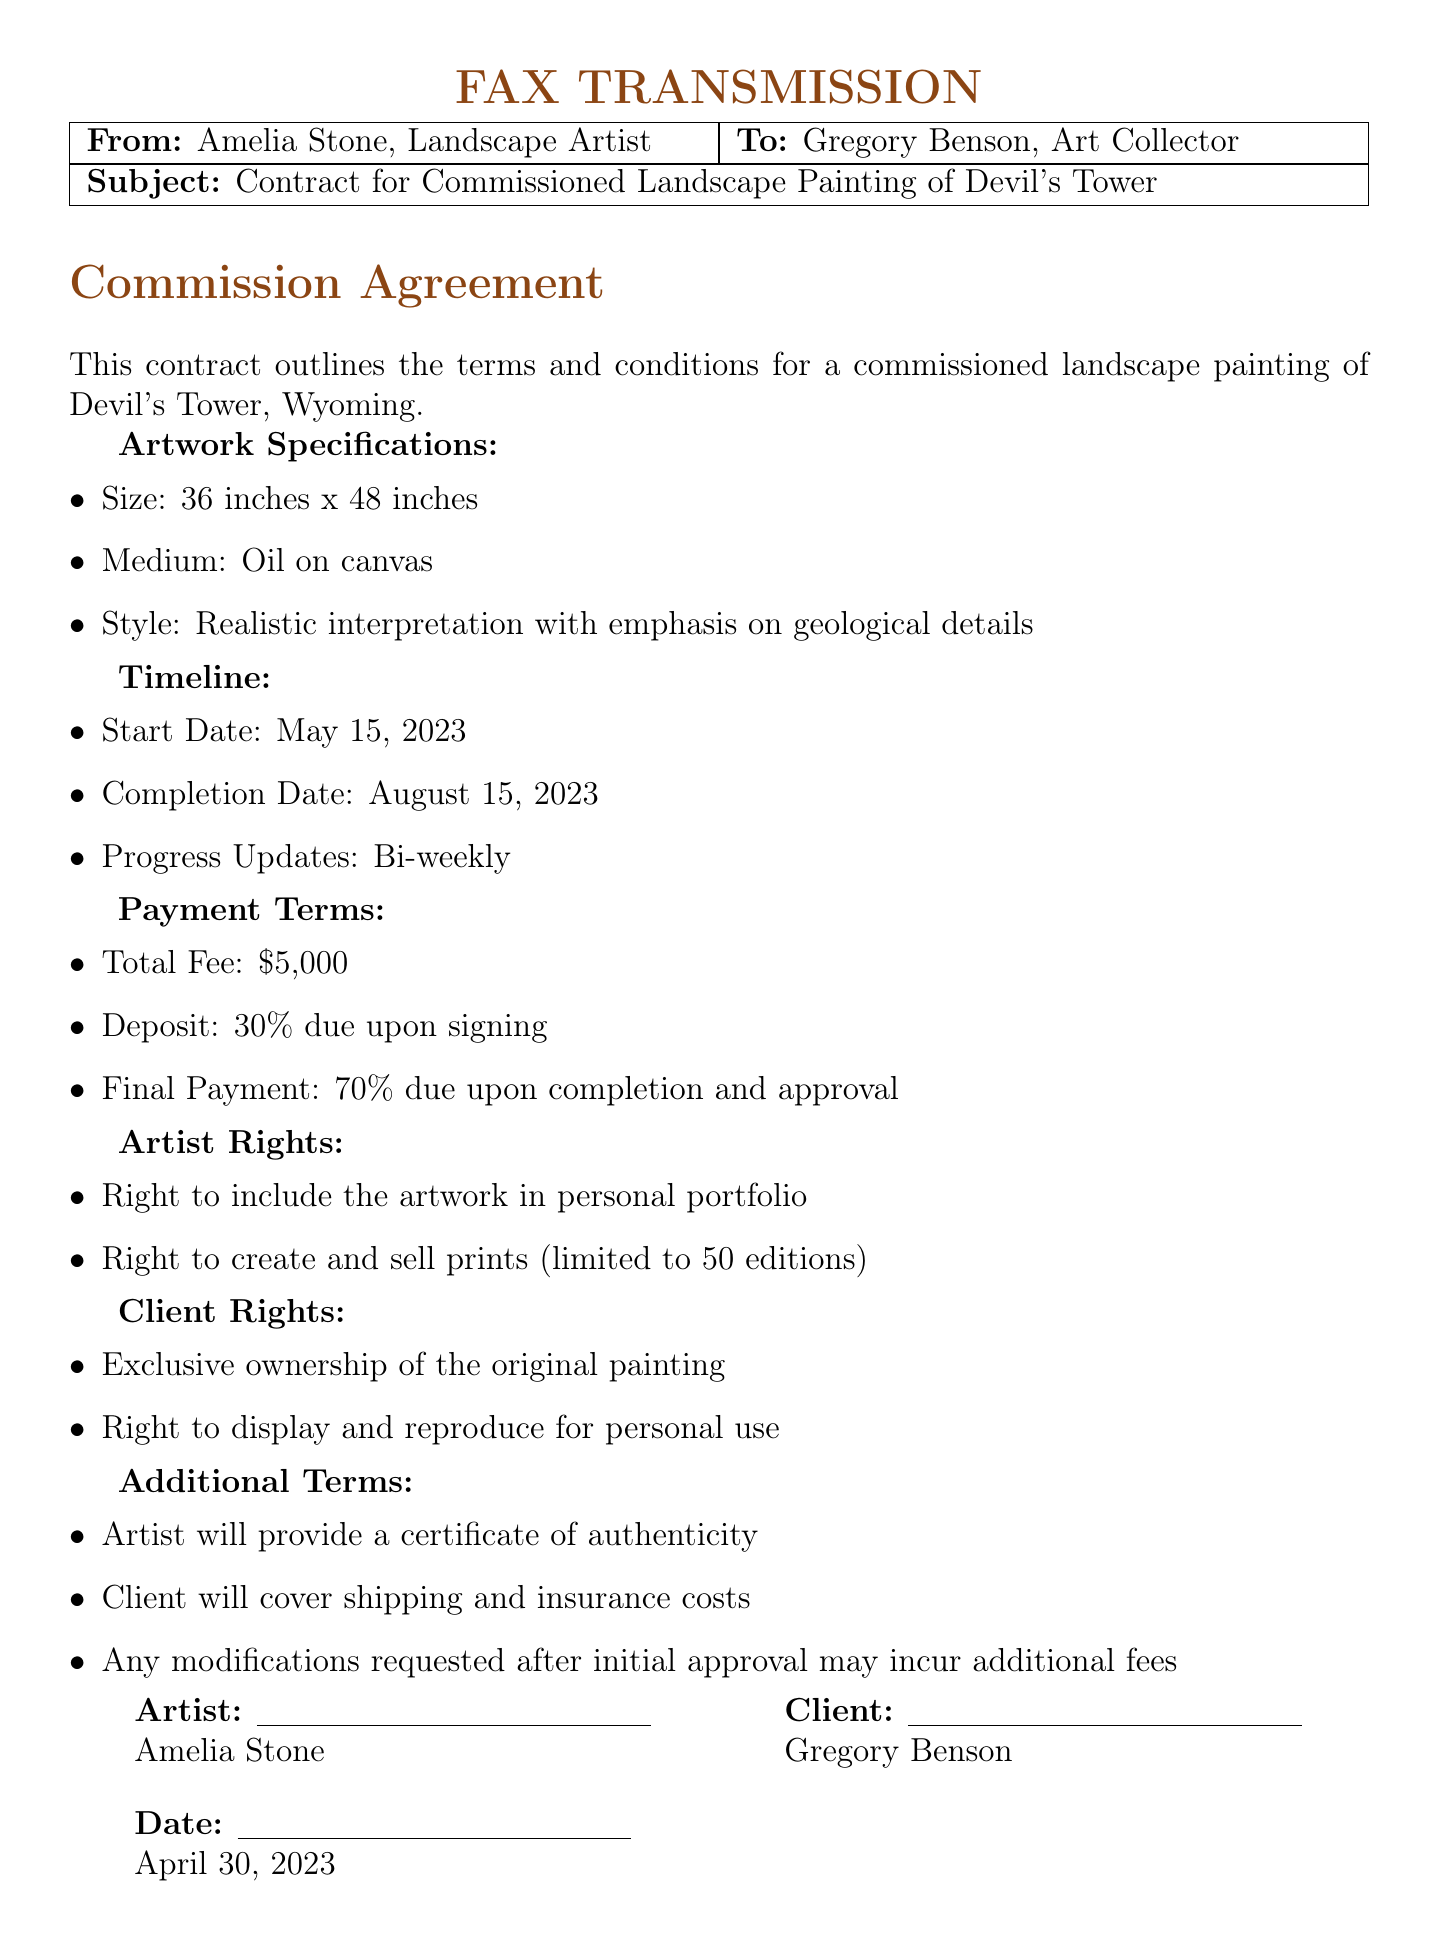What is the total fee for the commission? The total fee is stated explicitly in the payment terms section of the document.
Answer: $5,000 What is the size of the painting? The size of the painting is provided under the artwork specifications section.
Answer: 36 inches x 48 inches Who is the client? The client's name is mentioned in the fax header and the signature section of the document.
Answer: Gregory Benson What is the medium used for the painting? The medium is specified in the artwork specifications section of the document.
Answer: Oil on canvas When is the completion date? The completion date is outlined in the timeline section of the document.
Answer: August 15, 2023 What percentage of the fee is required as a deposit? The percentage is indicated in the payment terms section of the document.
Answer: 30% What rights does the artist retain? The artist's rights are explicitly listed in the document, requiring consideration of specific terms.
Answer: Right to include the artwork in personal portfolio What additional fees might occur? The document specifies conditions under which additional fees may apply, indicating a specific process.
Answer: Modifications after initial approval What is the start date of the commission? The start date is stated in the timeline section of the document.
Answer: May 15, 2023 